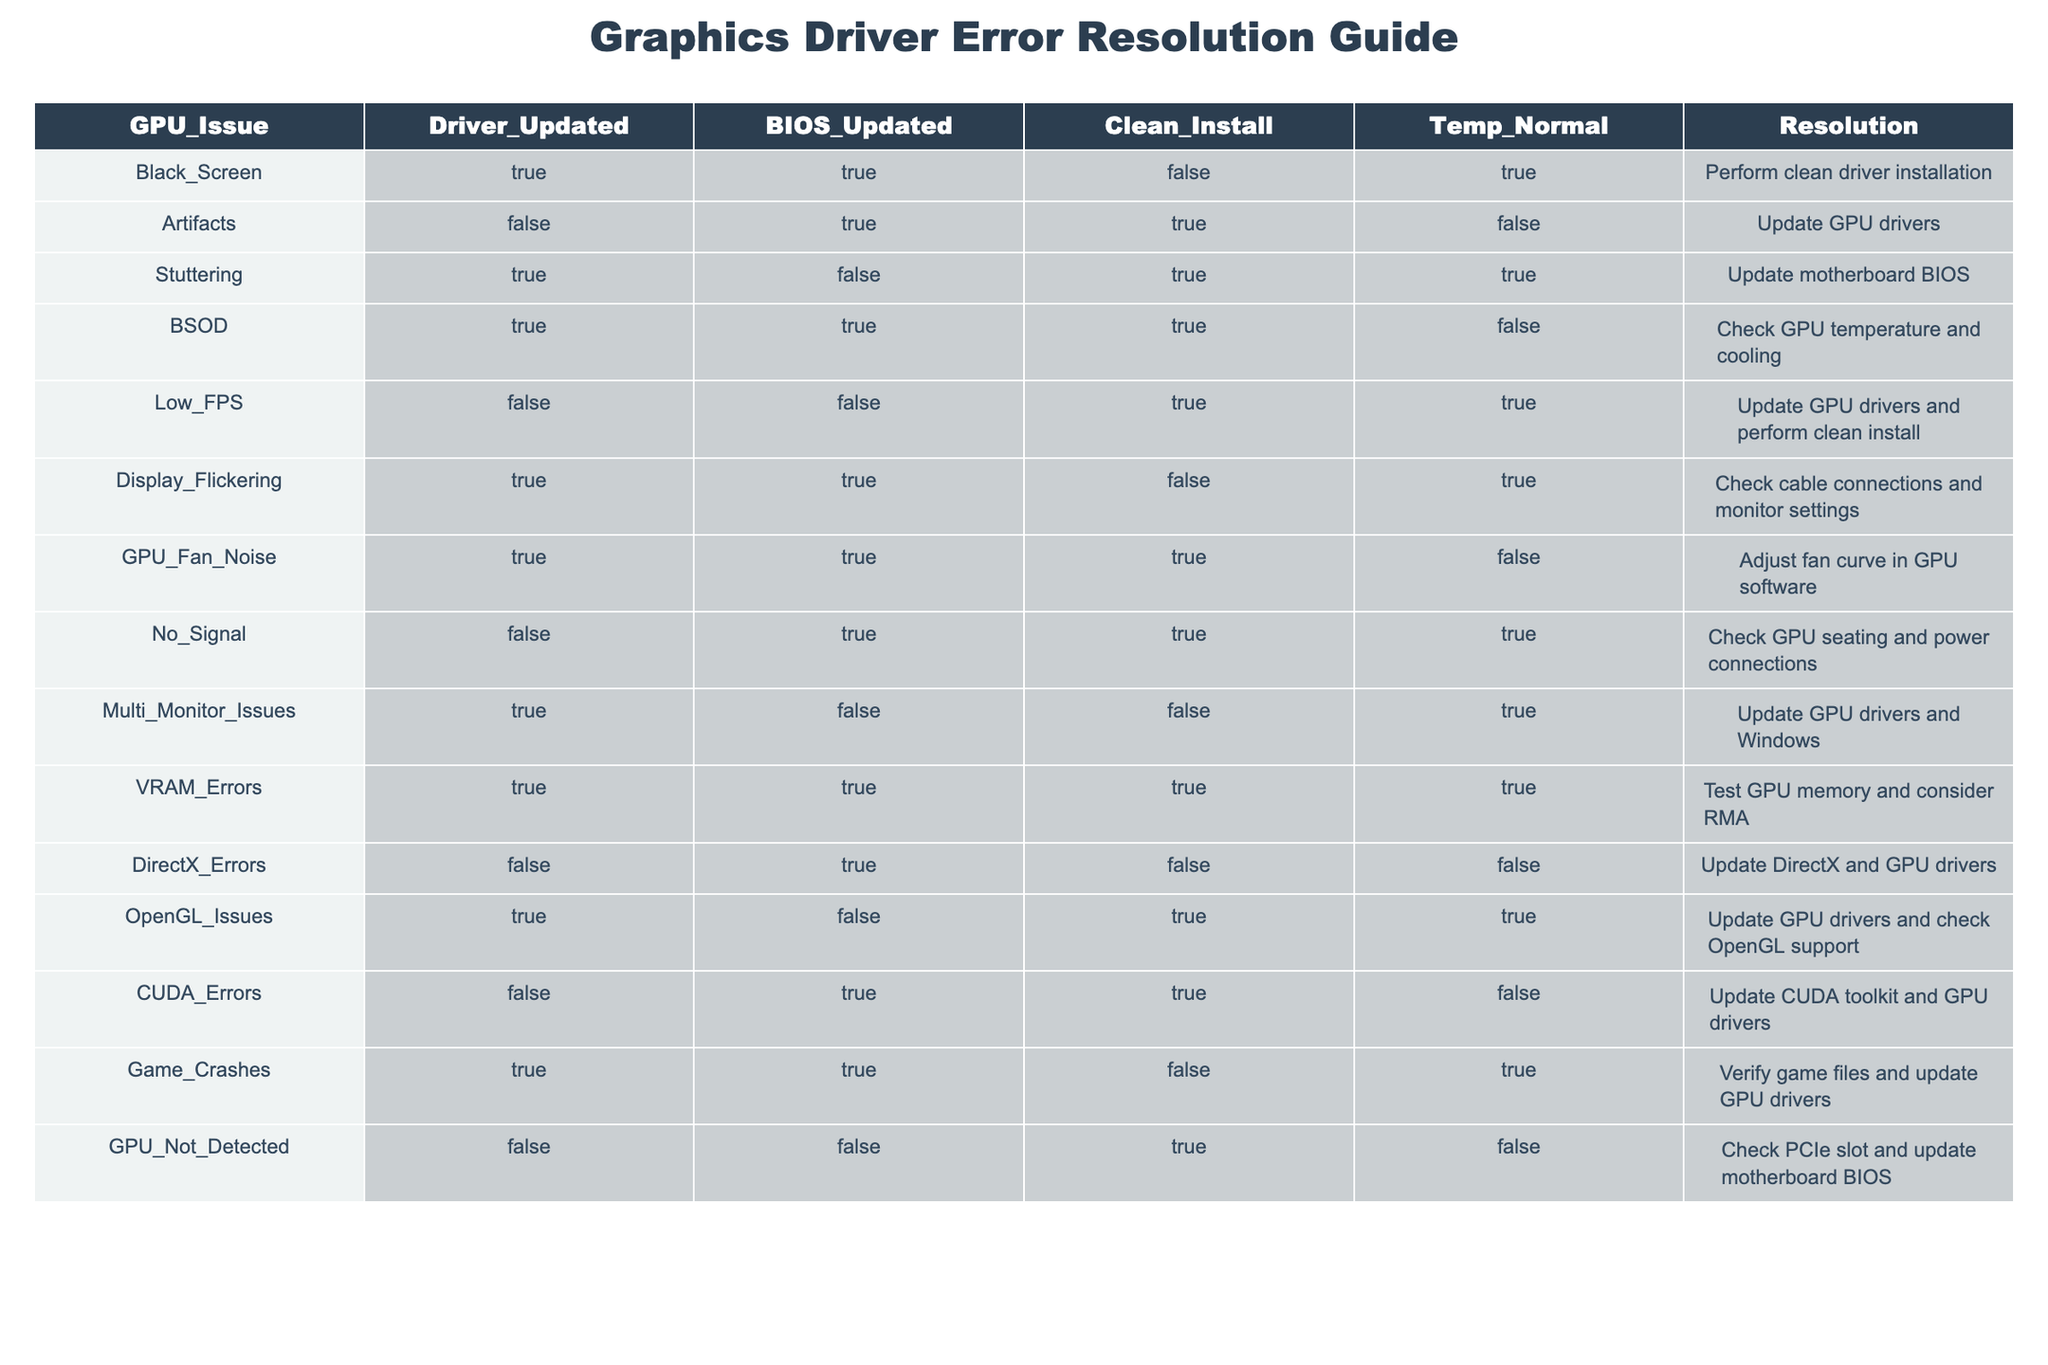What is the resolution for the "Black_Screen" issue? In the row corresponding to the "Black_Screen" issue, the resolution listed is "Perform clean driver installation".
Answer: Perform clean driver installation How many issues have the "Driver_Updated" status as TRUE? By scanning the "Driver_Updated" column, we find that there are 6 issues marked as TRUE: Black_Screen, Stuttering, BSOD, Display_Flickering, GPU_Fan_Noise, and Game_Crashes. Thus, there are 6 issues.
Answer: 6 Do any issues have both "Driver_Updated" and "Clean_Install" set to TRUE? Looking through the table, we see that "Stuttering", "BSOD", and "Game_Crashes" have both columns marked as TRUE. Thus, there are 3 such issues.
Answer: Yes What is the resolution for issues where "Temp_Normal" is FALSE? Filtering the "Temp_Normal" column for FALSE, we find that the corresponding resolutions are: "BSOD", "GPU_Fan_Noise", "Low_FPS", "GPU_Not_Detected", totaling 4 unique resolutions: "Check GPU temperature and cooling", "Adjust fan curve in GPU software", "Update GPU drivers and perform clean install", "Check PCIe slot and update motherboard BIOS".
Answer: 4 resolutions Which issues require a BIOS update among those listed? Analyzing the "BIOS_Updated" column, the issues with TRUE status for BIOS update are: "Artifacts", "BSOD", "No_Signal", "CUDA_Errors", totaling 4 issues.
Answer: 4 issues What is the resolution for the issue “No_Signal”? In the row for "No_Signal", the resolution listed is "Check GPU seating and power connections".
Answer: Check GPU seating and power connections Are there any issues that involve checking GPU memory? Examining the resolutions, we find that "VRAM_Errors" requires testing GPU memory. Thus, yes, there is at least one issue that involves this.
Answer: Yes What percentage of issues have "Clean_Install" set to TRUE? There are 6 issues with "Clean_Install" set to TRUE out of a total of 14 issues listed in the table. Calculating the percentage: (6/14) * 100 = approximately 42.86%.
Answer: 42.86% Which issue requires "Update GPU drivers" as a resolution but has "Driver_Updated" set to FALSE? Scanning the table, we find that "Low_FPS" has the resolution "Update GPU drivers" and "Driver_Updated" marked as FALSE. Hence, this issue meets the criteria.
Answer: Low_FPS 